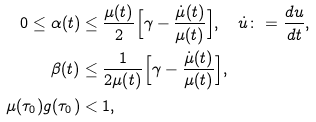Convert formula to latex. <formula><loc_0><loc_0><loc_500><loc_500>0 \leq \alpha ( t ) & \leq \frac { \mu ( t ) } { 2 } \Big { [ } \gamma - \frac { \dot { \mu } ( t ) } { \mu ( t ) } \Big { ] } , \quad \dot { u } \colon = \frac { d u } { d t } , \\ \beta ( t ) & \leq \frac { 1 } { 2 \mu ( t ) } \Big { [ } \gamma - \frac { \dot { \mu } ( t ) } { \mu ( t ) } \Big { ] } , \\ \mu ( \tau _ { 0 } ) g ( \tau _ { 0 } ) & < 1 ,</formula> 